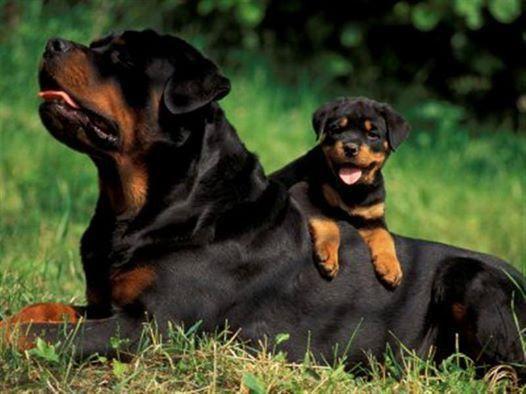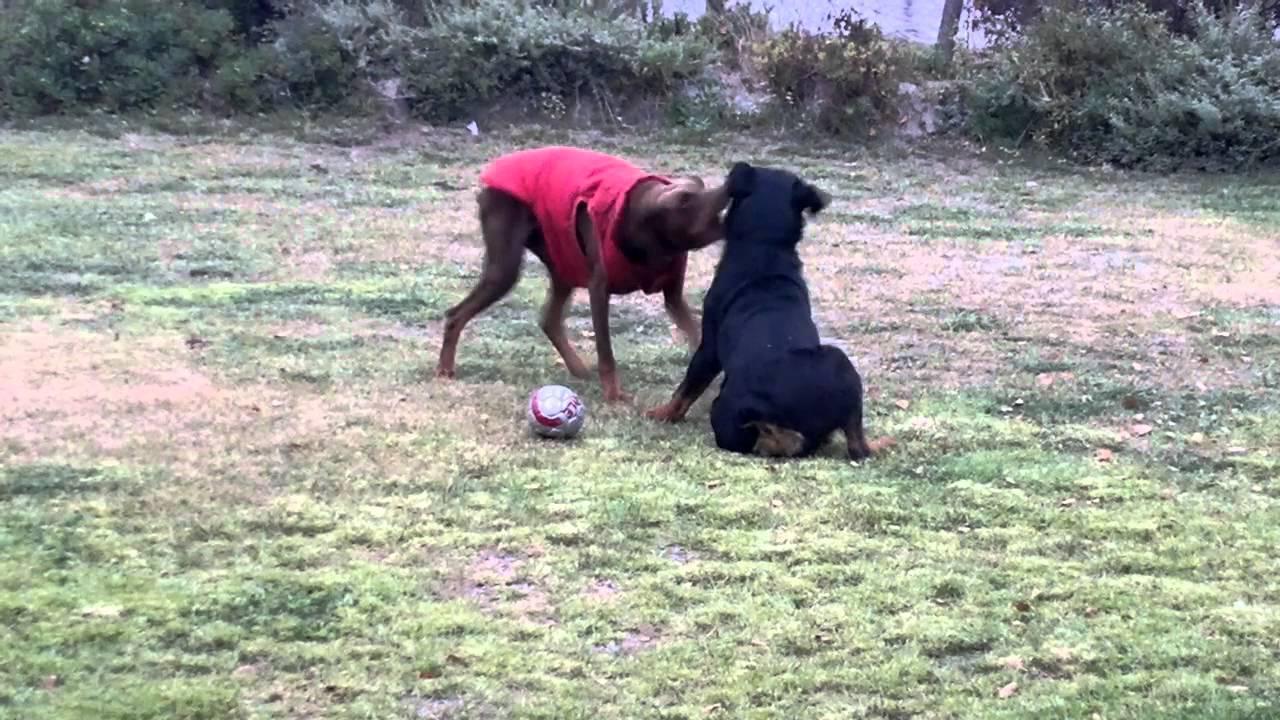The first image is the image on the left, the second image is the image on the right. Assess this claim about the two images: "There are exactly five dogs in total.". Correct or not? Answer yes or no. No. The first image is the image on the left, the second image is the image on the right. Examine the images to the left and right. Is the description "One picture has only three dogs posing together." accurate? Answer yes or no. No. 